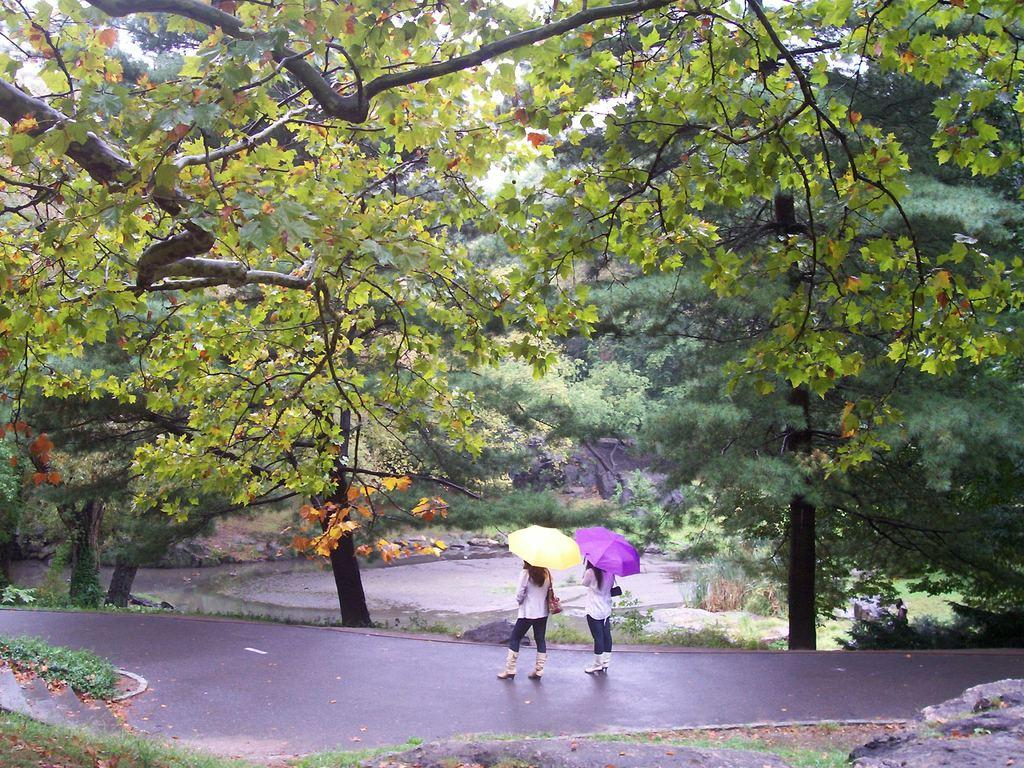How many people are in the image? There are two ladies in the image. What are the ladies wearing on their bodies? The ladies are wearing bags. What are the ladies holding in their hands? The ladies are holding umbrellas in their hands. Where are the ladies located in the image? The ladies are on the road. What can be seen in the background of the image? There are many trees in the background of the image. What type of powder is being used by the ladies in the image? There is no powder visible or mentioned in the image; the ladies are holding umbrellas and wearing bags. 